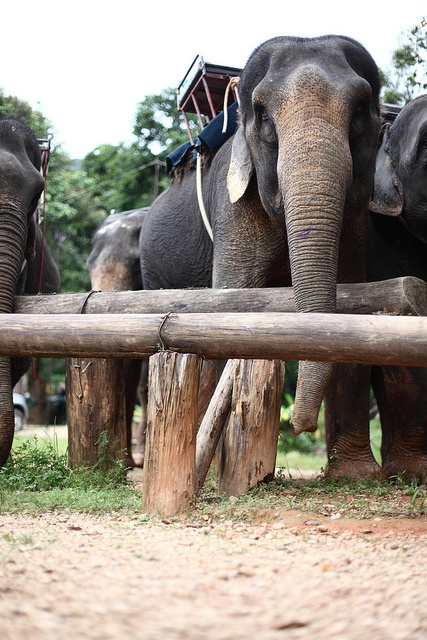Describe the objects in this image and their specific colors. I can see elephant in white, gray, black, and darkgray tones, elephant in white, black, and gray tones, elephant in white, black, and gray tones, elephant in white, darkgray, gray, lightgray, and black tones, and bench in white, black, gray, and darkgray tones in this image. 